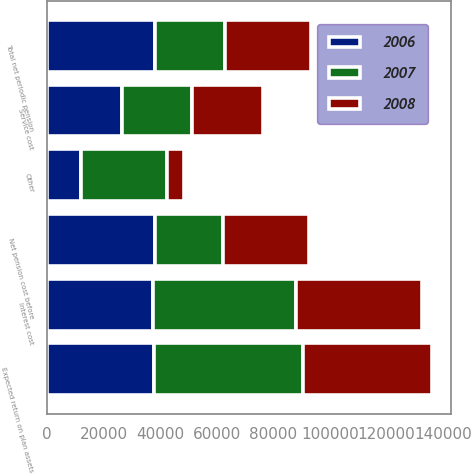Convert chart. <chart><loc_0><loc_0><loc_500><loc_500><stacked_bar_chart><ecel><fcel>Service cost<fcel>Interest cost<fcel>Expected return on plan assets<fcel>Other<fcel>Net pension cost before<fcel>Total net periodic pension<nl><fcel>2007<fcel>24763<fcel>50421<fcel>52884<fcel>30345<fcel>24120<fcel>24874<nl><fcel>2008<fcel>25366<fcel>44486<fcel>45481<fcel>5974<fcel>30345<fcel>30345<nl><fcel>2006<fcel>26313<fcel>37510<fcel>37577<fcel>11896<fcel>38142<fcel>38142<nl></chart> 